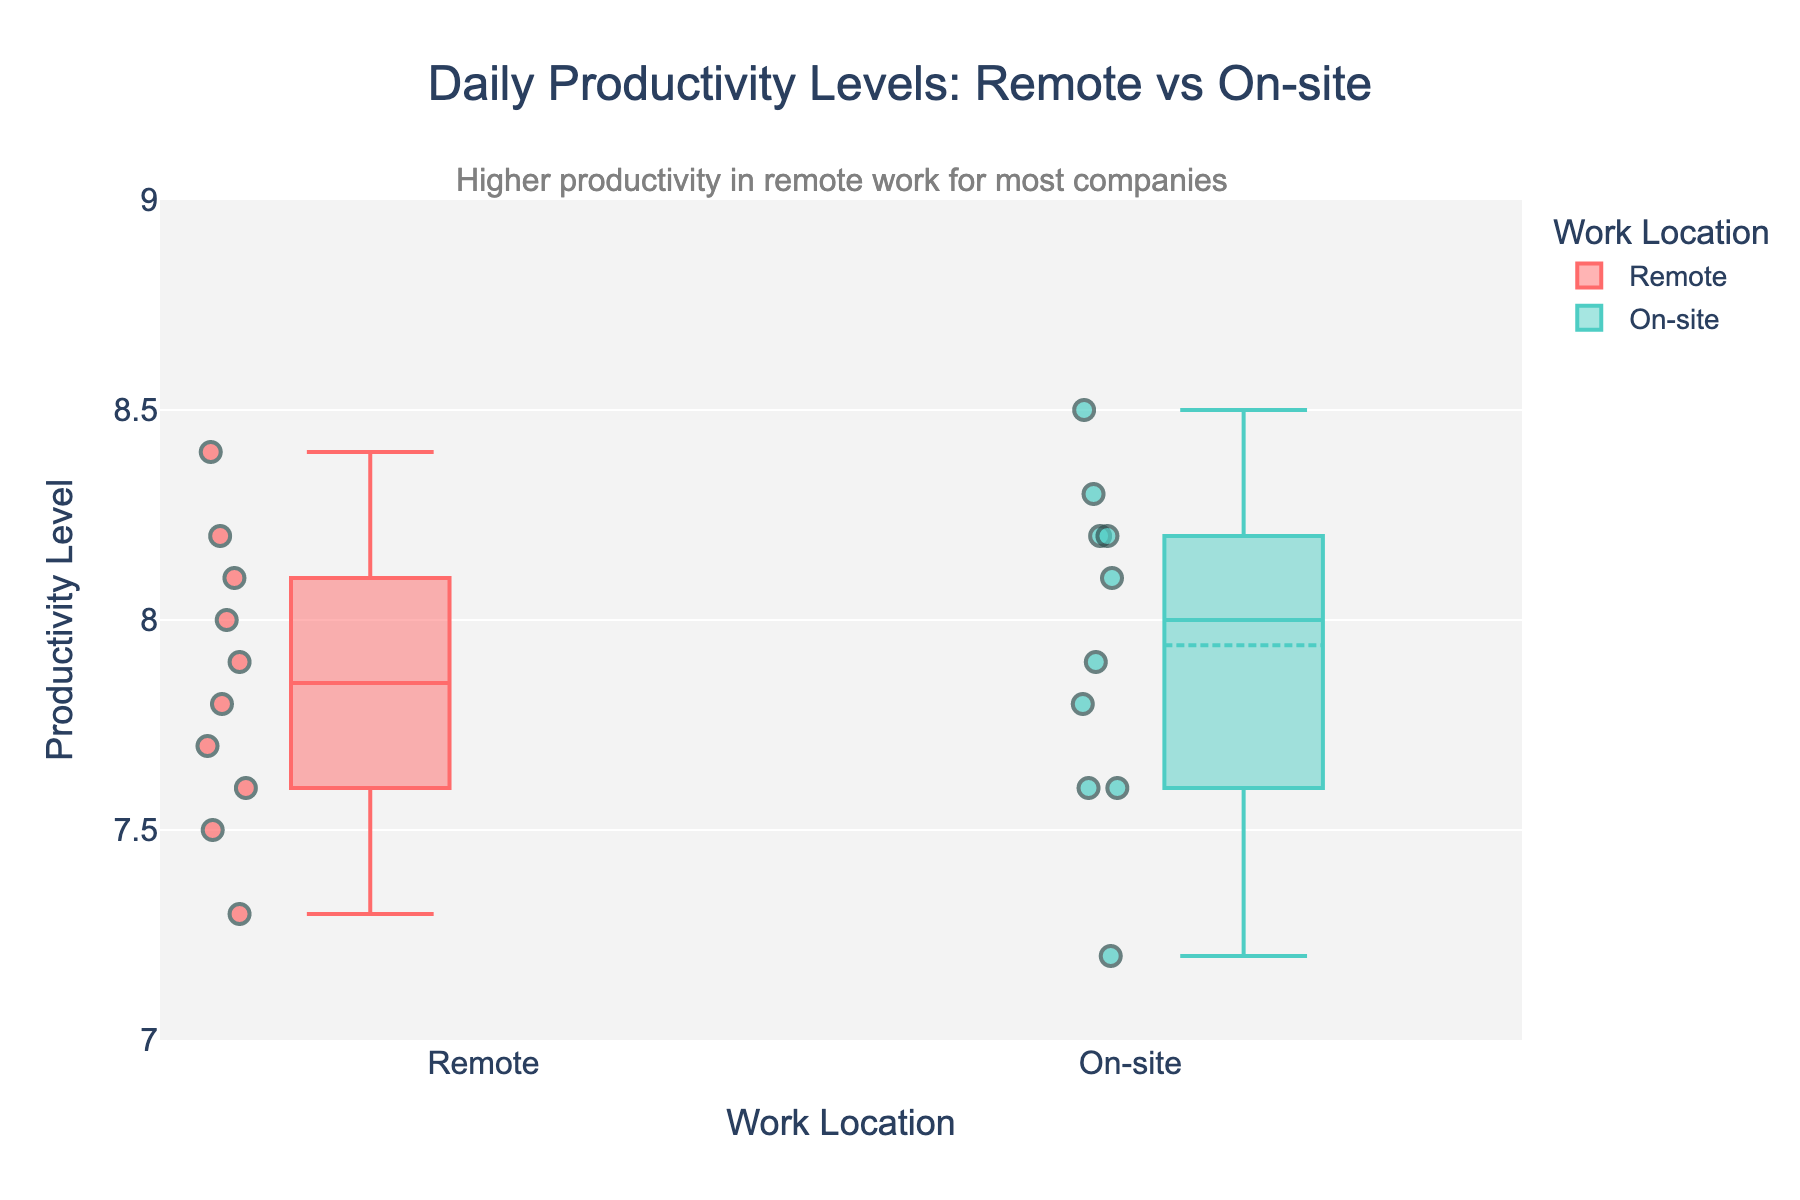what is the title of the box plot? As per the visual information, locate the title at the top of the figure, which states "Daily Productivity Levels: Remote vs On-site".
Answer: Daily Productivity Levels: Remote vs On-site What do the colors in the box plot represent? Examine the legend on the figure, which uses colors to distinguish between "Remote" and "On-site" work locations.
Answer: Work Location How many companies are included in the box plot for remote work? Look for the number of distinct data points or markers within the "Remote" box; noting there are 10 points, each representing a company.
Answer: 10 What is the median productivity level for on-site work? The median for "On-site" can be found by locating the line inside the box for "On-site"; it's approximately 8.0.
Answer: 8.0 Which work location has higher median productivity levels? Compare the median lines in both "Remote" and "On-site" boxes; "On-site" median at 8.0 is higher than "Remote" median at around 7.8.
Answer: On-site What is the interquartile range (IQR) for remote work? IQR is the difference between the upper quartile (Q3) and lower quartile (Q1). The Q3 is around 8.1 and Q1 is around 7.6. Thus, IQR = 8.1 - 7.6.
Answer: 0.5 Which company has the lowest productivity level in remote work? Identify the lowest data marker within "Remote"; "Twitter" is the company with a productivity level of 7.3.
Answer: Twitter Is there any company that shows higher productivity in remote work compared to on-site? Compare individual company points across both box plots. Tesla, with 8.4 in remote and 8.5 in on-site, shows higher productivity in on-site by a small margin; thus, no company has higher remote productivity.
Answer: No What does the annotation at the top of the figure indicate? The visual shows an annotation above the figure stating that remote work generally has higher productivity levels for most companies.
Answer: Higher productivity in remote work for most companies What is the range of productivity levels for on-site work? Locate the minimum and maximum whiskers in the "On-site" box. The range spans from about 7.2 (minimum, Twitter) to around 8.5 (maximum, Tesla).
Answer: 7.2 to 8.5 